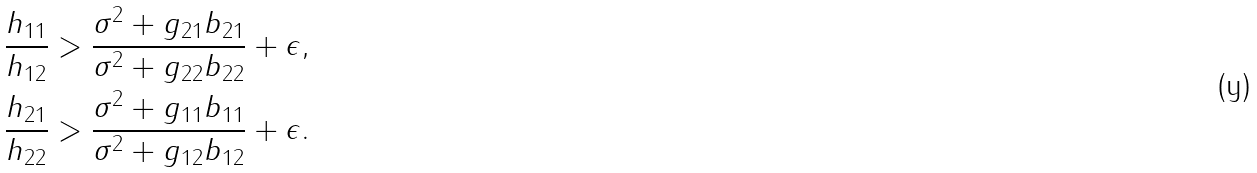Convert formula to latex. <formula><loc_0><loc_0><loc_500><loc_500>\frac { h _ { 1 1 } } { h _ { 1 2 } } & > \frac { \sigma ^ { 2 } + g _ { 2 1 } b _ { 2 1 } } { \sigma ^ { 2 } + g _ { 2 2 } b _ { 2 2 } } + \epsilon , \\ \frac { h _ { 2 1 } } { h _ { 2 2 } } & > \frac { \sigma ^ { 2 } + g _ { 1 1 } b _ { 1 1 } } { \sigma ^ { 2 } + g _ { 1 2 } b _ { 1 2 } } + \epsilon .</formula> 